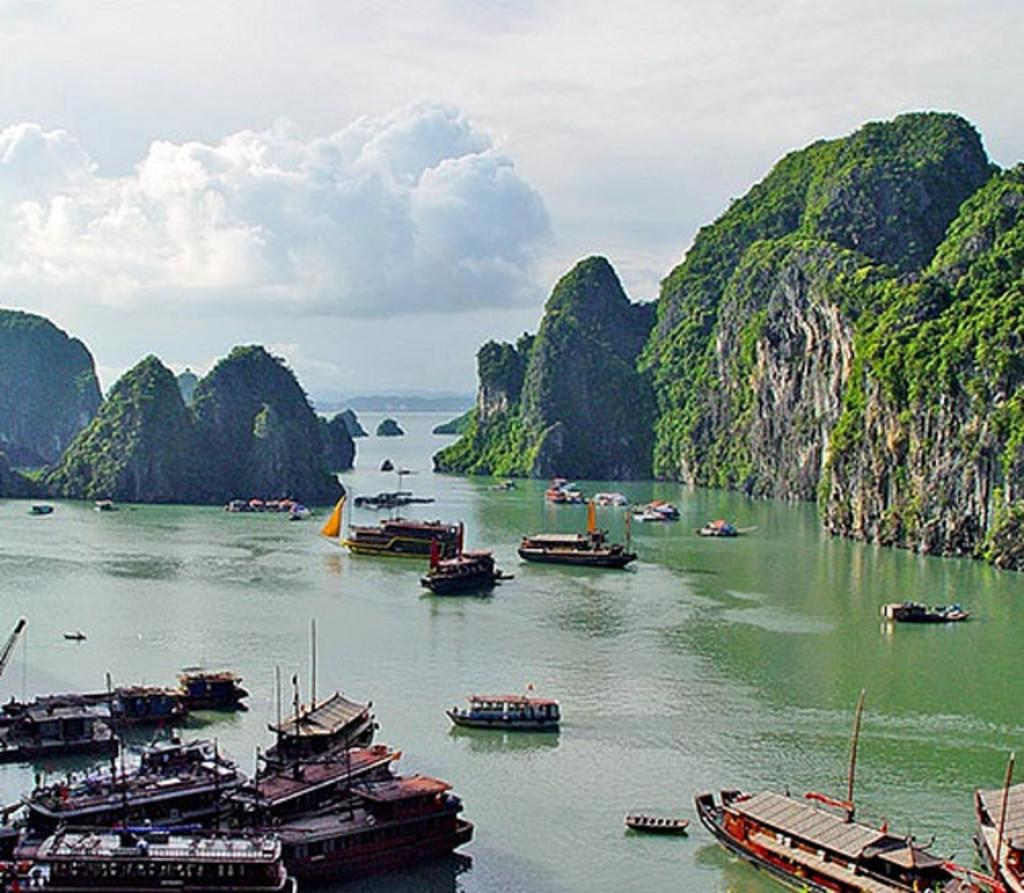What is happening on the surface of the water in the image? There are boats sailing on the surface of the water in the image. What can be seen in the background of the image? There are hills in the background of the image. What is visible at the top of the image? The sky is visible at the top of the image. What can be seen in the sky? There are clouds in the sky. Where are the sheep grazing in the image? There are no sheep present in the image. What type of letters can be seen on the boats in the image? There are no letters visible on the boats in the image. 